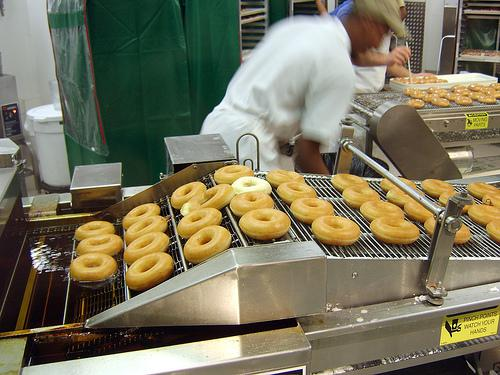Question: how many donuts will the man make?
Choices:
A. 400.
B. 299.
C. 2000.
D. 100.
Answer with the letter. Answer: C Question: what is the man doing?
Choices:
A. Baking a cake.
B. Riding a bike.
C. Taking out the trash.
D. Making donuts.
Answer with the letter. Answer: D 